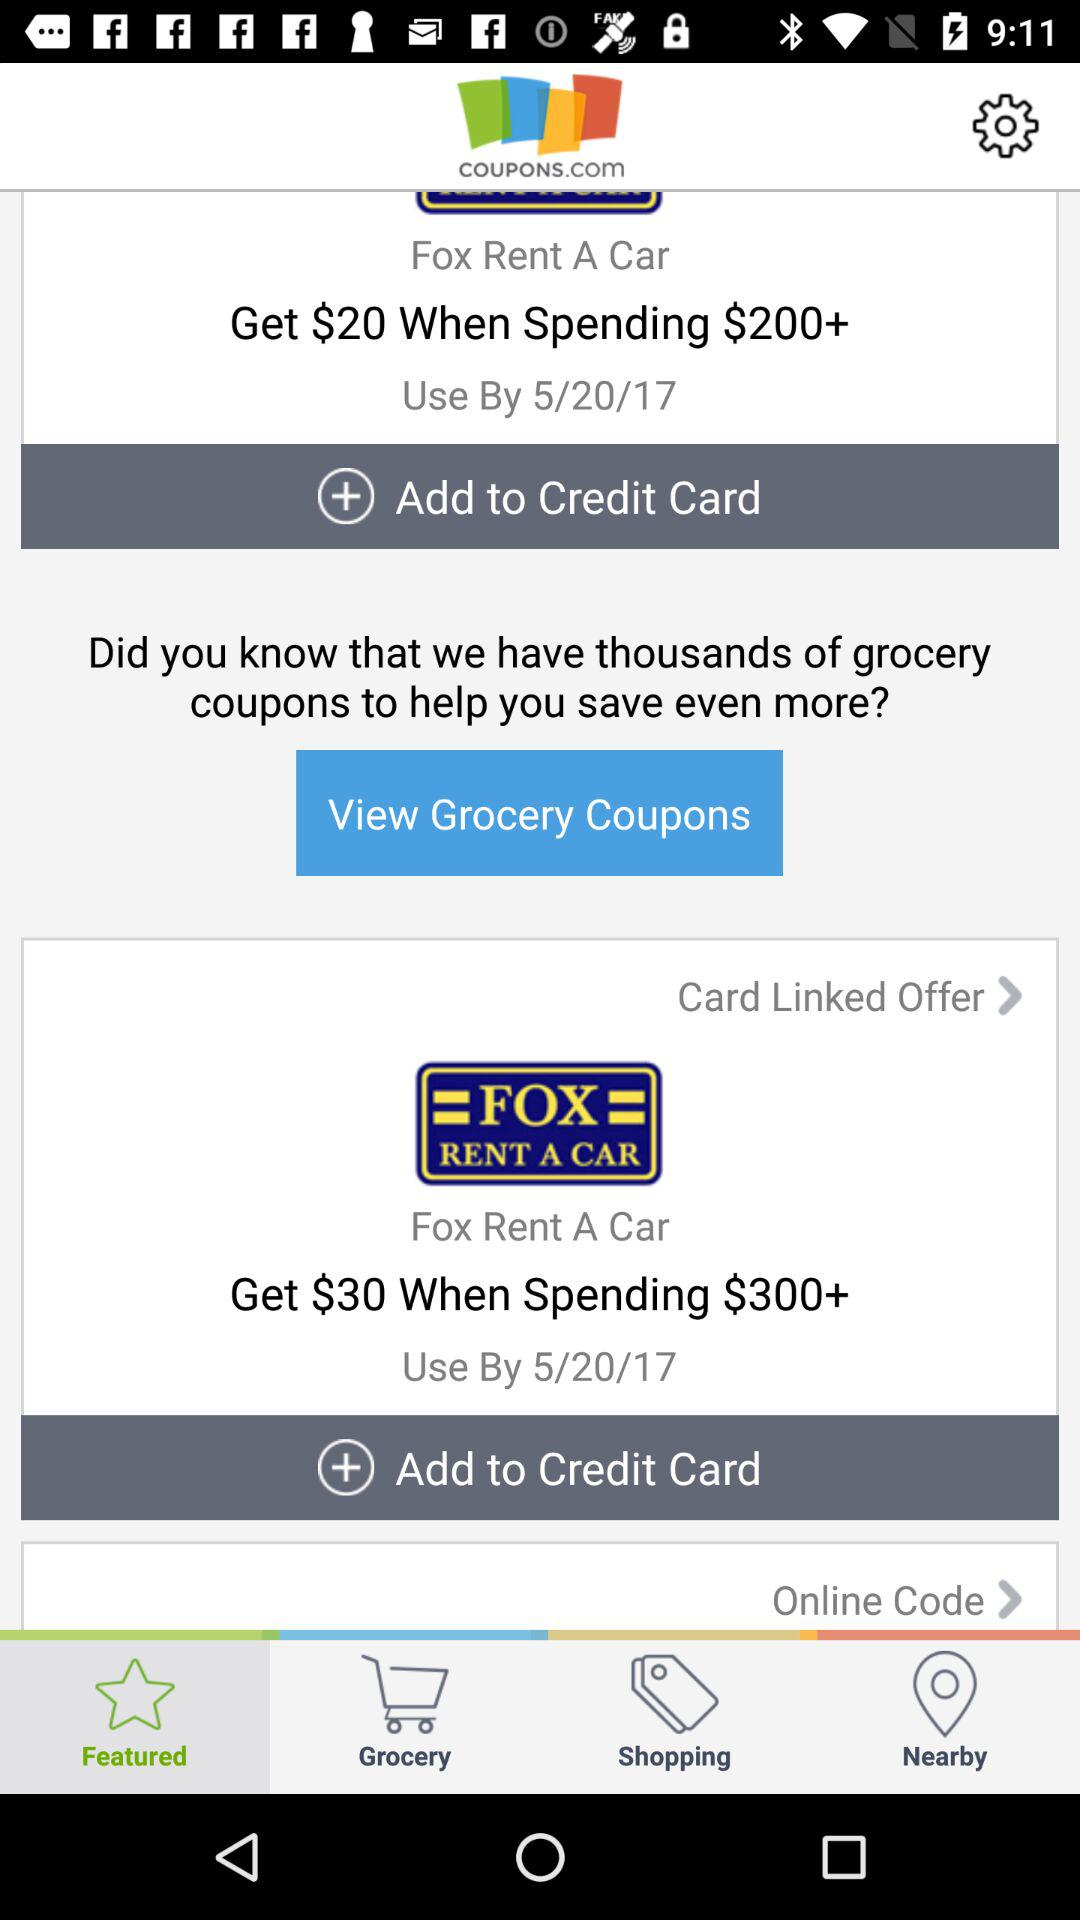Which credit card is used?
When the provided information is insufficient, respond with <no answer>. <no answer> 